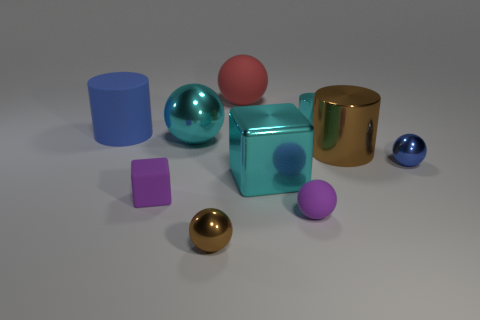There is a tiny cyan thing that is the same material as the large brown cylinder; what is its shape?
Make the answer very short. Cylinder. Is there any other thing that has the same shape as the large brown shiny object?
Offer a very short reply. Yes. There is a large rubber cylinder; how many big matte objects are behind it?
Ensure brevity in your answer.  1. Are any big matte spheres visible?
Make the answer very short. Yes. There is a rubber sphere that is behind the big matte thing that is on the left side of the tiny purple matte object to the left of the purple matte sphere; what color is it?
Keep it short and to the point. Red. Are there any shiny cylinders that are behind the ball left of the brown metallic ball?
Make the answer very short. Yes. There is a large rubber thing that is behind the small cylinder; does it have the same color as the metallic sphere to the right of the tiny cyan thing?
Your response must be concise. No. How many purple cubes have the same size as the brown cylinder?
Keep it short and to the point. 0. There is a metallic thing behind the blue cylinder; is its size the same as the small blue thing?
Offer a terse response. Yes. What is the shape of the blue rubber thing?
Offer a very short reply. Cylinder. 